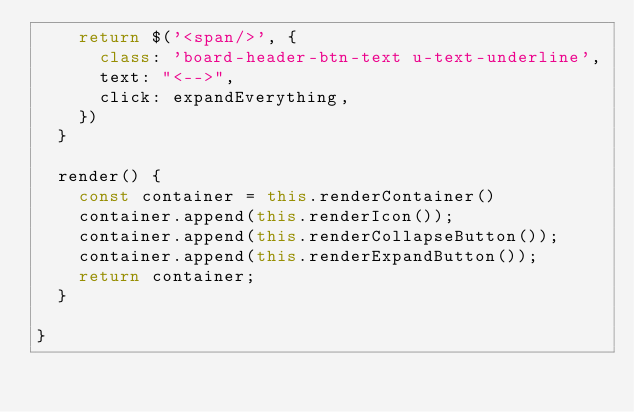<code> <loc_0><loc_0><loc_500><loc_500><_JavaScript_>    return $('<span/>', {
      class: 'board-header-btn-text u-text-underline',
      text: "<-->",
      click: expandEverything,
    })
  }

  render() {
    const container = this.renderContainer()
    container.append(this.renderIcon());
    container.append(this.renderCollapseButton());
    container.append(this.renderExpandButton());
    return container;
  }

}
</code> 